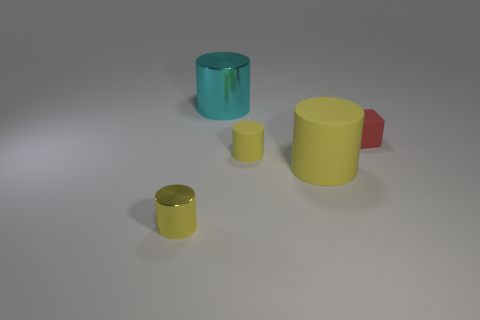What number of other objects are the same shape as the small red rubber object?
Make the answer very short. 0. What color is the shiny cylinder that is in front of the cyan shiny object?
Your answer should be compact. Yellow. Are the cube and the cyan cylinder made of the same material?
Keep it short and to the point. No. How many objects are either red things or tiny cylinders that are behind the yellow metallic cylinder?
Ensure brevity in your answer.  2. What size is the other matte cylinder that is the same color as the large rubber cylinder?
Keep it short and to the point. Small. What shape is the red object that is in front of the big cyan shiny thing?
Make the answer very short. Cube. Does the big rubber object on the right side of the cyan object have the same color as the large shiny thing?
Make the answer very short. No. There is another tiny object that is the same color as the small metal thing; what material is it?
Ensure brevity in your answer.  Rubber. There is a metal cylinder to the right of the yellow shiny cylinder; does it have the same size as the rubber block?
Provide a short and direct response. No. Are there any metal things that have the same color as the rubber block?
Provide a short and direct response. No. 